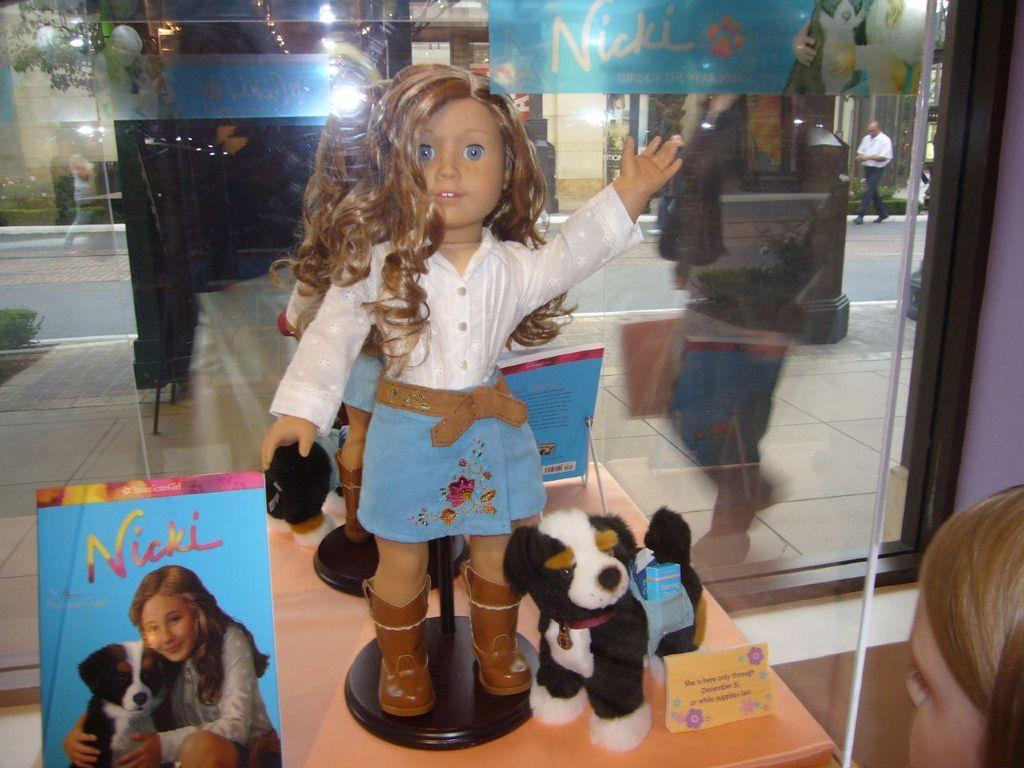Describe this image in one or two sentences. This image consists of a doll and toys kept on a table. On the right, there is a girl. In the background, we can see a road and a person walking. On the left, there is a book. 